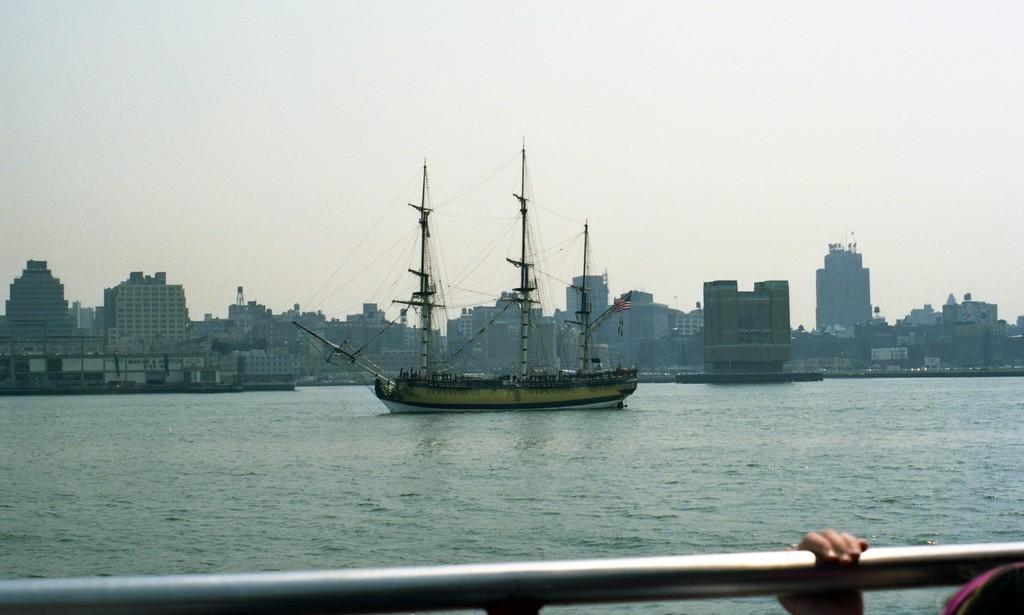Describe this image in one or two sentences. This picture is clicked outside. On the right corner we can see the hand of a person holding a metal rod. In the center we can see a boat in the water body and we can see the metal rods. In the background we can see the sky, buildings and many other objects. 